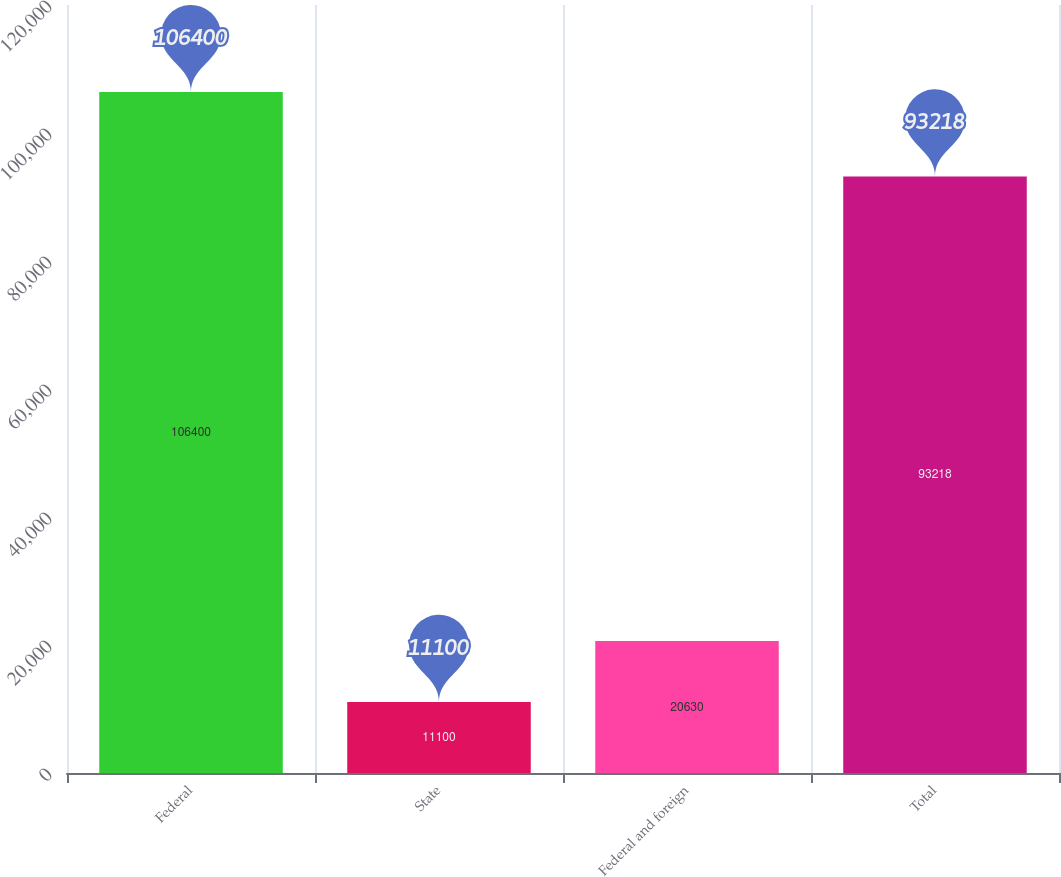Convert chart. <chart><loc_0><loc_0><loc_500><loc_500><bar_chart><fcel>Federal<fcel>State<fcel>Federal and foreign<fcel>Total<nl><fcel>106400<fcel>11100<fcel>20630<fcel>93218<nl></chart> 